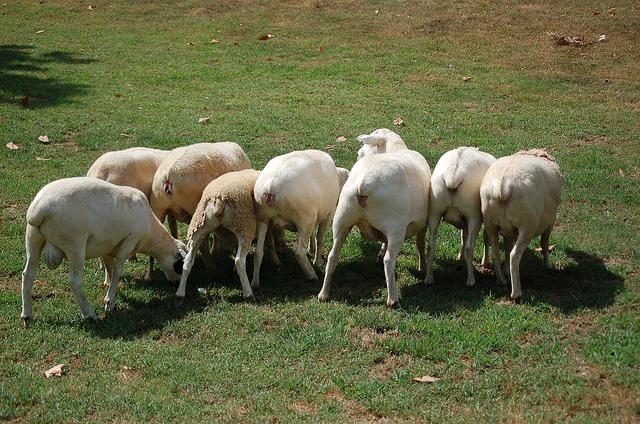How many sheep are there?
Short answer required. 8. How many brightly colored animals are there?
Short answer required. 8. How many sheep are facing the camera?
Give a very brief answer. 0. Is there a boat in the picture?
Concise answer only. No. What are the sheep looking at?
Quick response, please. Grass. What color is the grass?
Be succinct. Green. Are there animals eating?
Short answer required. Yes. 